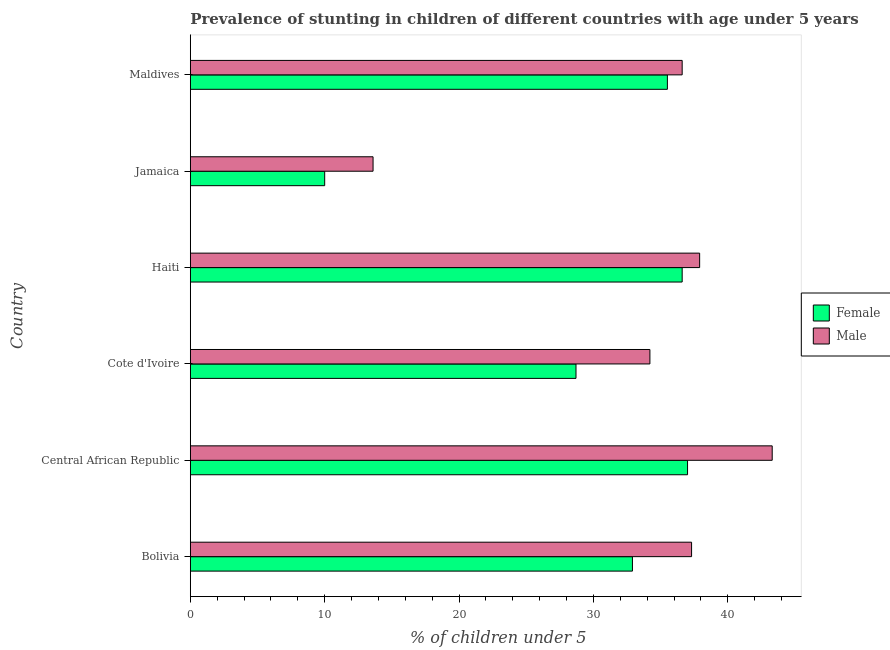How many different coloured bars are there?
Make the answer very short. 2. Are the number of bars on each tick of the Y-axis equal?
Your answer should be compact. Yes. How many bars are there on the 4th tick from the bottom?
Ensure brevity in your answer.  2. What is the label of the 6th group of bars from the top?
Offer a very short reply. Bolivia. What is the percentage of stunted male children in Central African Republic?
Your answer should be compact. 43.3. Across all countries, what is the maximum percentage of stunted male children?
Keep it short and to the point. 43.3. In which country was the percentage of stunted male children maximum?
Give a very brief answer. Central African Republic. In which country was the percentage of stunted female children minimum?
Your answer should be compact. Jamaica. What is the total percentage of stunted female children in the graph?
Give a very brief answer. 180.7. What is the difference between the percentage of stunted male children in Bolivia and that in Jamaica?
Keep it short and to the point. 23.7. What is the difference between the percentage of stunted female children in Central African Republic and the percentage of stunted male children in Cote d'Ivoire?
Provide a succinct answer. 2.8. What is the average percentage of stunted male children per country?
Ensure brevity in your answer.  33.82. What is the difference between the percentage of stunted female children and percentage of stunted male children in Haiti?
Your answer should be very brief. -1.3. What is the ratio of the percentage of stunted male children in Jamaica to that in Maldives?
Your answer should be compact. 0.37. Is the difference between the percentage of stunted male children in Cote d'Ivoire and Haiti greater than the difference between the percentage of stunted female children in Cote d'Ivoire and Haiti?
Your answer should be very brief. Yes. What is the difference between the highest and the second highest percentage of stunted male children?
Keep it short and to the point. 5.4. What is the difference between the highest and the lowest percentage of stunted male children?
Offer a very short reply. 29.7. In how many countries, is the percentage of stunted female children greater than the average percentage of stunted female children taken over all countries?
Your answer should be compact. 4. Is the sum of the percentage of stunted female children in Central African Republic and Cote d'Ivoire greater than the maximum percentage of stunted male children across all countries?
Your answer should be compact. Yes. What does the 2nd bar from the top in Haiti represents?
Provide a succinct answer. Female. What is the difference between two consecutive major ticks on the X-axis?
Keep it short and to the point. 10. Are the values on the major ticks of X-axis written in scientific E-notation?
Keep it short and to the point. No. Does the graph contain grids?
Offer a very short reply. No. How many legend labels are there?
Offer a very short reply. 2. What is the title of the graph?
Offer a very short reply. Prevalence of stunting in children of different countries with age under 5 years. What is the label or title of the X-axis?
Make the answer very short.  % of children under 5. What is the label or title of the Y-axis?
Your answer should be very brief. Country. What is the  % of children under 5 in Female in Bolivia?
Provide a succinct answer. 32.9. What is the  % of children under 5 of Male in Bolivia?
Give a very brief answer. 37.3. What is the  % of children under 5 in Female in Central African Republic?
Ensure brevity in your answer.  37. What is the  % of children under 5 in Male in Central African Republic?
Offer a very short reply. 43.3. What is the  % of children under 5 in Female in Cote d'Ivoire?
Provide a short and direct response. 28.7. What is the  % of children under 5 of Male in Cote d'Ivoire?
Offer a very short reply. 34.2. What is the  % of children under 5 in Female in Haiti?
Ensure brevity in your answer.  36.6. What is the  % of children under 5 in Male in Haiti?
Make the answer very short. 37.9. What is the  % of children under 5 of Male in Jamaica?
Provide a succinct answer. 13.6. What is the  % of children under 5 of Female in Maldives?
Make the answer very short. 35.5. What is the  % of children under 5 in Male in Maldives?
Provide a succinct answer. 36.6. Across all countries, what is the maximum  % of children under 5 of Female?
Your answer should be very brief. 37. Across all countries, what is the maximum  % of children under 5 of Male?
Provide a succinct answer. 43.3. Across all countries, what is the minimum  % of children under 5 of Female?
Keep it short and to the point. 10. Across all countries, what is the minimum  % of children under 5 of Male?
Your answer should be very brief. 13.6. What is the total  % of children under 5 of Female in the graph?
Provide a succinct answer. 180.7. What is the total  % of children under 5 of Male in the graph?
Give a very brief answer. 202.9. What is the difference between the  % of children under 5 in Female in Bolivia and that in Haiti?
Your response must be concise. -3.7. What is the difference between the  % of children under 5 in Male in Bolivia and that in Haiti?
Offer a terse response. -0.6. What is the difference between the  % of children under 5 of Female in Bolivia and that in Jamaica?
Your answer should be very brief. 22.9. What is the difference between the  % of children under 5 of Male in Bolivia and that in Jamaica?
Provide a short and direct response. 23.7. What is the difference between the  % of children under 5 of Female in Central African Republic and that in Cote d'Ivoire?
Give a very brief answer. 8.3. What is the difference between the  % of children under 5 of Male in Central African Republic and that in Cote d'Ivoire?
Offer a very short reply. 9.1. What is the difference between the  % of children under 5 of Female in Central African Republic and that in Haiti?
Your response must be concise. 0.4. What is the difference between the  % of children under 5 of Female in Central African Republic and that in Jamaica?
Keep it short and to the point. 27. What is the difference between the  % of children under 5 in Male in Central African Republic and that in Jamaica?
Give a very brief answer. 29.7. What is the difference between the  % of children under 5 in Female in Central African Republic and that in Maldives?
Provide a short and direct response. 1.5. What is the difference between the  % of children under 5 of Male in Central African Republic and that in Maldives?
Provide a short and direct response. 6.7. What is the difference between the  % of children under 5 in Female in Cote d'Ivoire and that in Haiti?
Your answer should be very brief. -7.9. What is the difference between the  % of children under 5 of Female in Cote d'Ivoire and that in Jamaica?
Your answer should be compact. 18.7. What is the difference between the  % of children under 5 of Male in Cote d'Ivoire and that in Jamaica?
Offer a terse response. 20.6. What is the difference between the  % of children under 5 in Female in Cote d'Ivoire and that in Maldives?
Give a very brief answer. -6.8. What is the difference between the  % of children under 5 of Female in Haiti and that in Jamaica?
Provide a short and direct response. 26.6. What is the difference between the  % of children under 5 in Male in Haiti and that in Jamaica?
Your answer should be very brief. 24.3. What is the difference between the  % of children under 5 of Female in Haiti and that in Maldives?
Provide a short and direct response. 1.1. What is the difference between the  % of children under 5 in Female in Jamaica and that in Maldives?
Give a very brief answer. -25.5. What is the difference between the  % of children under 5 of Female in Bolivia and the  % of children under 5 of Male in Cote d'Ivoire?
Ensure brevity in your answer.  -1.3. What is the difference between the  % of children under 5 of Female in Bolivia and the  % of children under 5 of Male in Haiti?
Keep it short and to the point. -5. What is the difference between the  % of children under 5 in Female in Bolivia and the  % of children under 5 in Male in Jamaica?
Provide a short and direct response. 19.3. What is the difference between the  % of children under 5 in Female in Bolivia and the  % of children under 5 in Male in Maldives?
Keep it short and to the point. -3.7. What is the difference between the  % of children under 5 of Female in Central African Republic and the  % of children under 5 of Male in Haiti?
Your answer should be compact. -0.9. What is the difference between the  % of children under 5 in Female in Central African Republic and the  % of children under 5 in Male in Jamaica?
Your answer should be very brief. 23.4. What is the difference between the  % of children under 5 of Female in Central African Republic and the  % of children under 5 of Male in Maldives?
Make the answer very short. 0.4. What is the difference between the  % of children under 5 of Female in Cote d'Ivoire and the  % of children under 5 of Male in Maldives?
Keep it short and to the point. -7.9. What is the difference between the  % of children under 5 in Female in Haiti and the  % of children under 5 in Male in Jamaica?
Give a very brief answer. 23. What is the difference between the  % of children under 5 of Female in Haiti and the  % of children under 5 of Male in Maldives?
Make the answer very short. 0. What is the difference between the  % of children under 5 of Female in Jamaica and the  % of children under 5 of Male in Maldives?
Provide a succinct answer. -26.6. What is the average  % of children under 5 in Female per country?
Your answer should be very brief. 30.12. What is the average  % of children under 5 in Male per country?
Your answer should be very brief. 33.82. What is the difference between the  % of children under 5 in Female and  % of children under 5 in Male in Bolivia?
Your answer should be very brief. -4.4. What is the difference between the  % of children under 5 in Female and  % of children under 5 in Male in Central African Republic?
Ensure brevity in your answer.  -6.3. What is the ratio of the  % of children under 5 in Female in Bolivia to that in Central African Republic?
Offer a terse response. 0.89. What is the ratio of the  % of children under 5 of Male in Bolivia to that in Central African Republic?
Your answer should be very brief. 0.86. What is the ratio of the  % of children under 5 in Female in Bolivia to that in Cote d'Ivoire?
Your response must be concise. 1.15. What is the ratio of the  % of children under 5 of Male in Bolivia to that in Cote d'Ivoire?
Provide a short and direct response. 1.09. What is the ratio of the  % of children under 5 in Female in Bolivia to that in Haiti?
Provide a short and direct response. 0.9. What is the ratio of the  % of children under 5 in Male in Bolivia to that in Haiti?
Give a very brief answer. 0.98. What is the ratio of the  % of children under 5 in Female in Bolivia to that in Jamaica?
Keep it short and to the point. 3.29. What is the ratio of the  % of children under 5 in Male in Bolivia to that in Jamaica?
Offer a very short reply. 2.74. What is the ratio of the  % of children under 5 in Female in Bolivia to that in Maldives?
Provide a short and direct response. 0.93. What is the ratio of the  % of children under 5 of Male in Bolivia to that in Maldives?
Ensure brevity in your answer.  1.02. What is the ratio of the  % of children under 5 of Female in Central African Republic to that in Cote d'Ivoire?
Offer a terse response. 1.29. What is the ratio of the  % of children under 5 in Male in Central African Republic to that in Cote d'Ivoire?
Give a very brief answer. 1.27. What is the ratio of the  % of children under 5 of Female in Central African Republic to that in Haiti?
Your answer should be compact. 1.01. What is the ratio of the  % of children under 5 of Male in Central African Republic to that in Haiti?
Keep it short and to the point. 1.14. What is the ratio of the  % of children under 5 of Male in Central African Republic to that in Jamaica?
Offer a terse response. 3.18. What is the ratio of the  % of children under 5 of Female in Central African Republic to that in Maldives?
Give a very brief answer. 1.04. What is the ratio of the  % of children under 5 in Male in Central African Republic to that in Maldives?
Provide a short and direct response. 1.18. What is the ratio of the  % of children under 5 in Female in Cote d'Ivoire to that in Haiti?
Keep it short and to the point. 0.78. What is the ratio of the  % of children under 5 of Male in Cote d'Ivoire to that in Haiti?
Ensure brevity in your answer.  0.9. What is the ratio of the  % of children under 5 of Female in Cote d'Ivoire to that in Jamaica?
Your answer should be compact. 2.87. What is the ratio of the  % of children under 5 in Male in Cote d'Ivoire to that in Jamaica?
Provide a succinct answer. 2.51. What is the ratio of the  % of children under 5 of Female in Cote d'Ivoire to that in Maldives?
Ensure brevity in your answer.  0.81. What is the ratio of the  % of children under 5 in Male in Cote d'Ivoire to that in Maldives?
Provide a succinct answer. 0.93. What is the ratio of the  % of children under 5 of Female in Haiti to that in Jamaica?
Offer a terse response. 3.66. What is the ratio of the  % of children under 5 in Male in Haiti to that in Jamaica?
Provide a short and direct response. 2.79. What is the ratio of the  % of children under 5 of Female in Haiti to that in Maldives?
Your response must be concise. 1.03. What is the ratio of the  % of children under 5 in Male in Haiti to that in Maldives?
Your answer should be compact. 1.04. What is the ratio of the  % of children under 5 in Female in Jamaica to that in Maldives?
Your response must be concise. 0.28. What is the ratio of the  % of children under 5 in Male in Jamaica to that in Maldives?
Provide a succinct answer. 0.37. What is the difference between the highest and the second highest  % of children under 5 in Male?
Provide a short and direct response. 5.4. What is the difference between the highest and the lowest  % of children under 5 in Male?
Give a very brief answer. 29.7. 